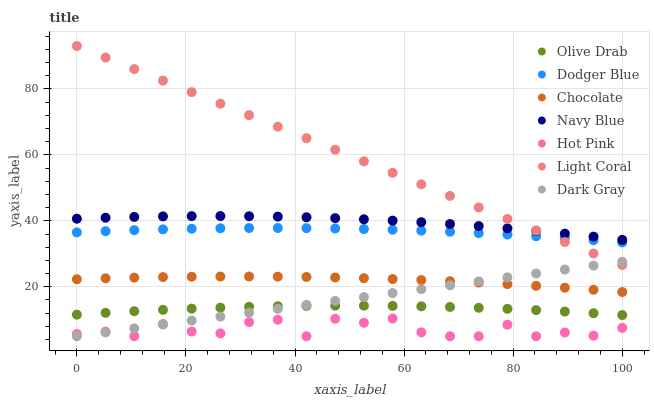Does Hot Pink have the minimum area under the curve?
Answer yes or no. Yes. Does Light Coral have the maximum area under the curve?
Answer yes or no. Yes. Does Navy Blue have the minimum area under the curve?
Answer yes or no. No. Does Navy Blue have the maximum area under the curve?
Answer yes or no. No. Is Dark Gray the smoothest?
Answer yes or no. Yes. Is Hot Pink the roughest?
Answer yes or no. Yes. Is Navy Blue the smoothest?
Answer yes or no. No. Is Navy Blue the roughest?
Answer yes or no. No. Does Dark Gray have the lowest value?
Answer yes or no. Yes. Does Navy Blue have the lowest value?
Answer yes or no. No. Does Light Coral have the highest value?
Answer yes or no. Yes. Does Navy Blue have the highest value?
Answer yes or no. No. Is Hot Pink less than Olive Drab?
Answer yes or no. Yes. Is Navy Blue greater than Hot Pink?
Answer yes or no. Yes. Does Navy Blue intersect Light Coral?
Answer yes or no. Yes. Is Navy Blue less than Light Coral?
Answer yes or no. No. Is Navy Blue greater than Light Coral?
Answer yes or no. No. Does Hot Pink intersect Olive Drab?
Answer yes or no. No. 